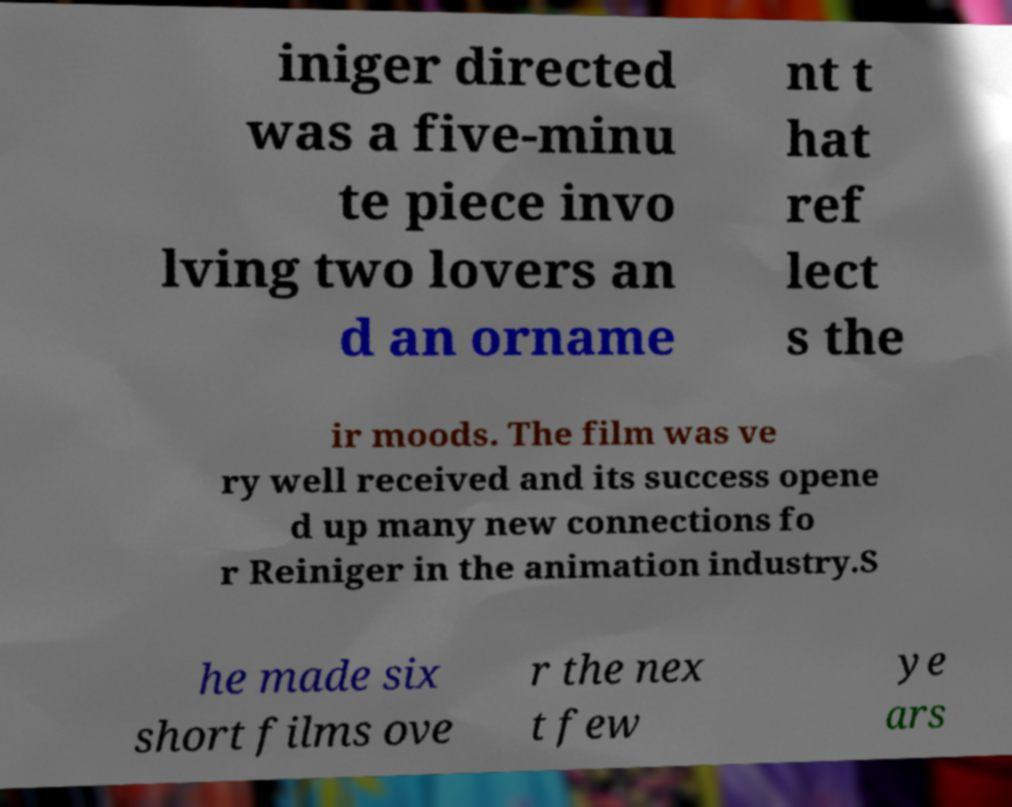What messages or text are displayed in this image? I need them in a readable, typed format. iniger directed was a five-minu te piece invo lving two lovers an d an orname nt t hat ref lect s the ir moods. The film was ve ry well received and its success opene d up many new connections fo r Reiniger in the animation industry.S he made six short films ove r the nex t few ye ars 